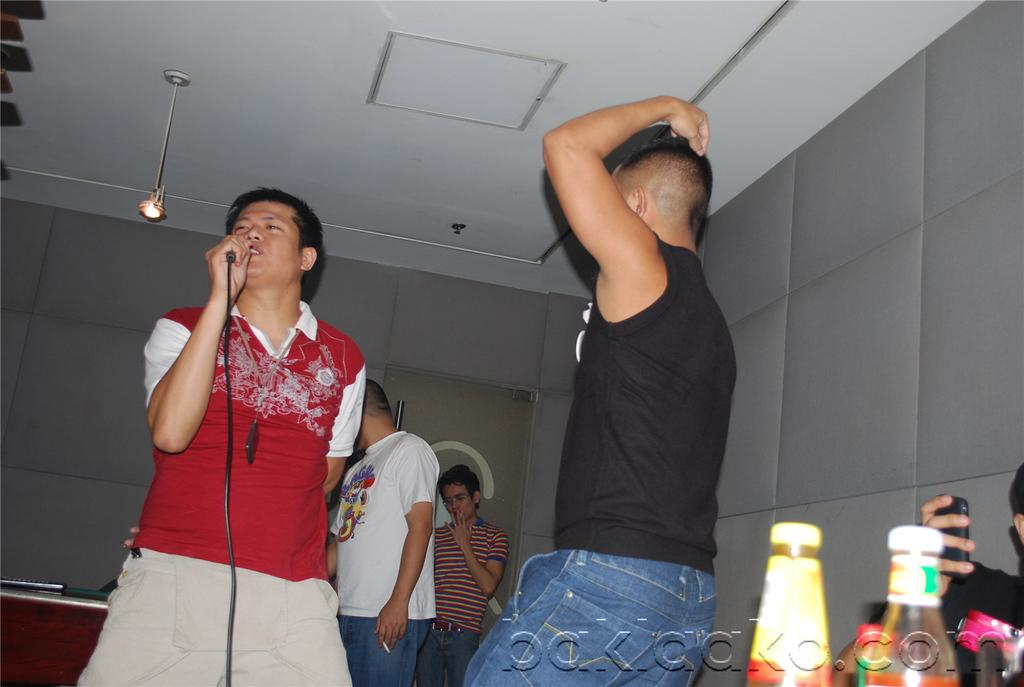How many people are in the image? There is a group of people in the image. What are the people in the image doing? The people are standing on the floor. Can you describe the person in the front? The person in the front is holding a microphone. What color is the blood on the thumb of the person holding the microphone? There is no blood or thumb visible in the image; the person in the front is holding a microphone. 